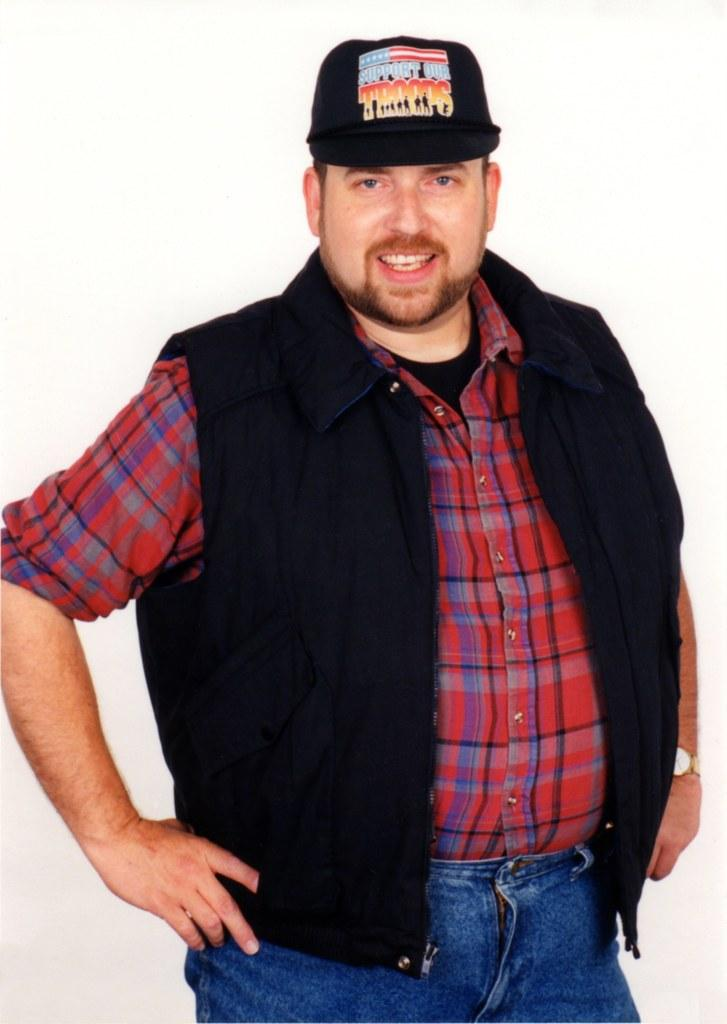What is the main subject of the image? There is a person in the image. What is the person wearing on their upper body? The person is wearing a red shirt and a black jacket. What type of pants is the person wearing? The person is wearing jeans. What is the person wearing on their head? The person is wearing a cap. What is the person's facial expression in the image? The person is smiling. What color is the background of the image? The background of the image is white. What type of fuel can be seen in the image? There is no fuel present in the image; it features a person wearing various clothing items and accessories. Can you tell me how many ants are visible in the image? There are no ants present in the image. 